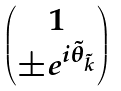Convert formula to latex. <formula><loc_0><loc_0><loc_500><loc_500>\begin{pmatrix} 1 \\ \pm e ^ { i \tilde { \theta } _ { \tilde { k } } } \end{pmatrix}</formula> 